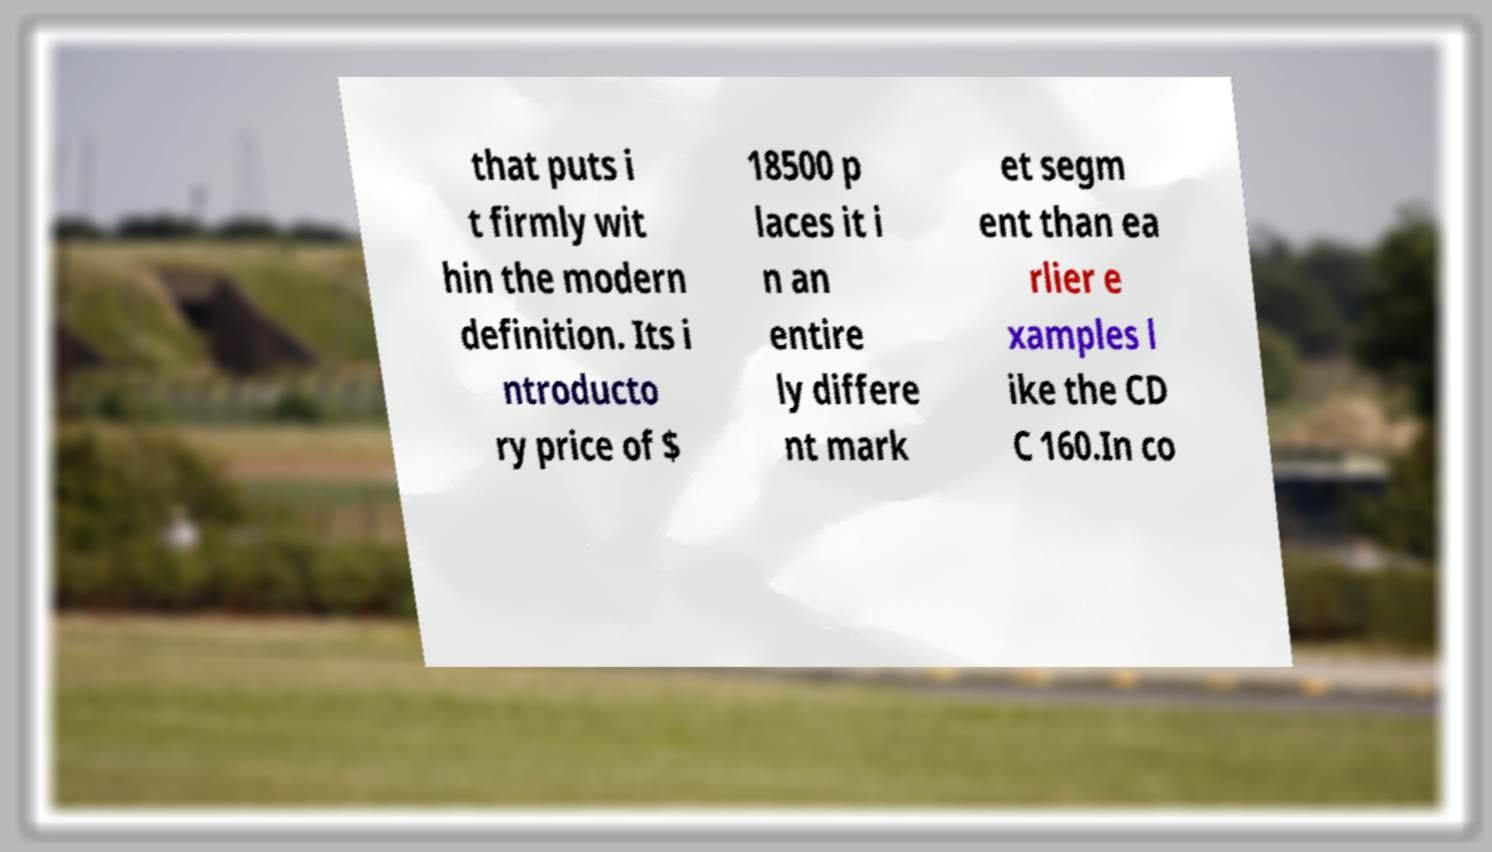Please read and relay the text visible in this image. What does it say? that puts i t firmly wit hin the modern definition. Its i ntroducto ry price of $ 18500 p laces it i n an entire ly differe nt mark et segm ent than ea rlier e xamples l ike the CD C 160.In co 